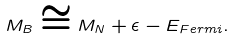Convert formula to latex. <formula><loc_0><loc_0><loc_500><loc_500>M _ { B } \cong M _ { N } + \epsilon - E _ { F e r m i } .</formula> 